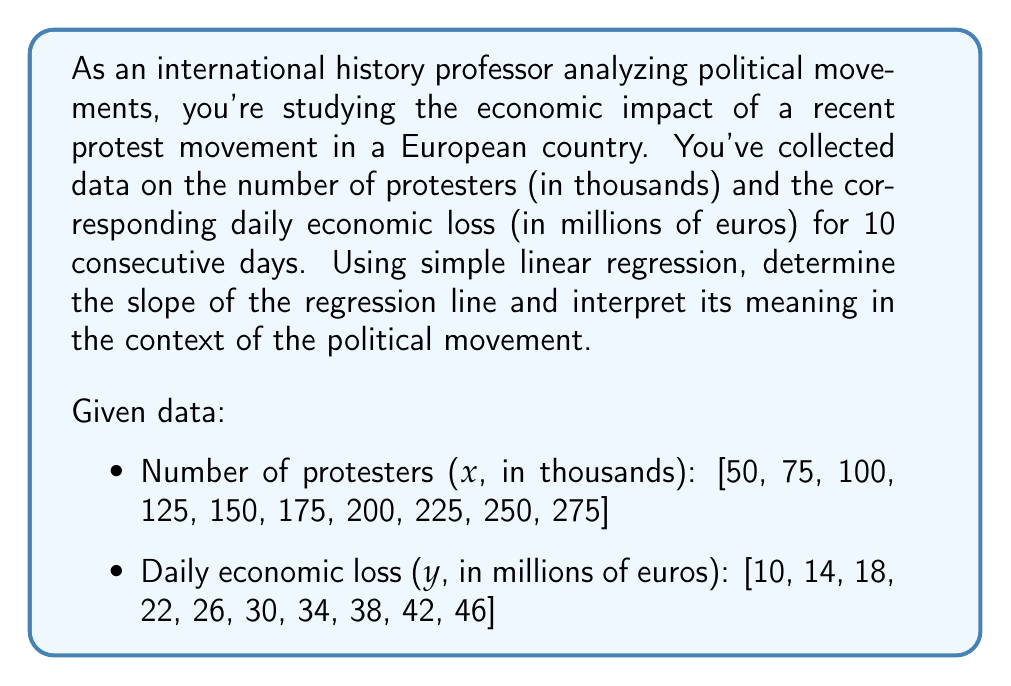Can you solve this math problem? To solve this problem, we'll use simple linear regression to find the relationship between the number of protesters and the daily economic loss. The slope of the regression line will indicate how much the economic loss increases for each additional thousand protesters.

Step 1: Calculate the means of x and y
$$\bar{x} = \frac{\sum_{i=1}^{n} x_i}{n} = \frac{1625}{10} = 162.5$$
$$\bar{y} = \frac{\sum_{i=1}^{n} y_i}{n} = \frac{280}{10} = 28$$

Step 2: Calculate the slope (b) using the formula:
$$b = \frac{\sum_{i=1}^{n} (x_i - \bar{x})(y_i - \bar{y})}{\sum_{i=1}^{n} (x_i - \bar{x})^2}$$

Step 3: Calculate the numerator and denominator separately:
Numerator: $\sum_{i=1}^{n} (x_i - \bar{x})(y_i - \bar{y}) = 39,375$
Denominator: $\sum_{i=1}^{n} (x_i - \bar{x})^2 = 54,375$

Step 4: Calculate the slope:
$$b = \frac{39,375}{54,375} = 0.7241379310344828$$

Step 5: Interpret the result:
The slope of 0.7241 indicates that for each additional thousand protesters, the daily economic loss increases by approximately 0.7241 million euros.
Answer: The slope of the regression line is approximately 0.7241, meaning that for each additional thousand protesters, the daily economic loss increases by about 0.7241 million euros. 